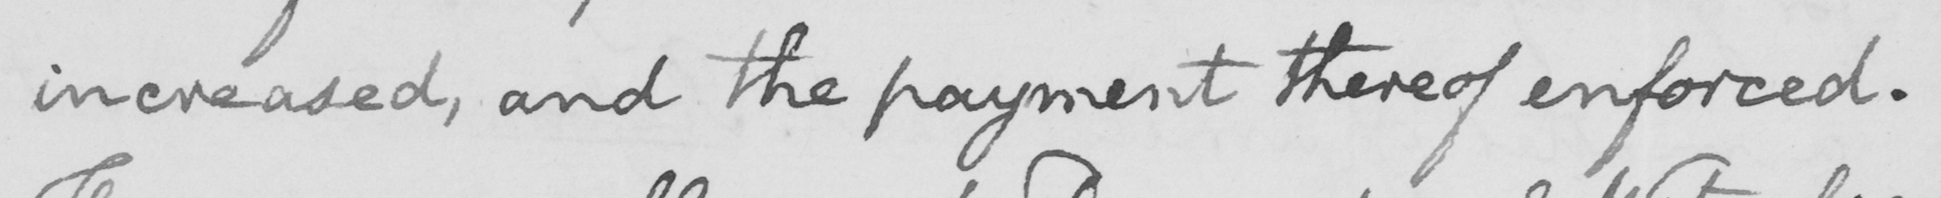What text is written in this handwritten line? increased, and the payment thereof be enforced. 